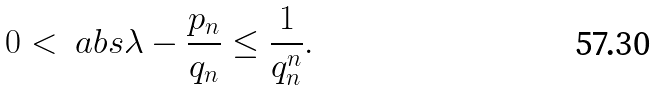Convert formula to latex. <formula><loc_0><loc_0><loc_500><loc_500>0 < \ a b s { \lambda - \frac { p _ { n } } { q _ { n } } } \leq \frac { 1 } { q _ { n } ^ { n } } .</formula> 